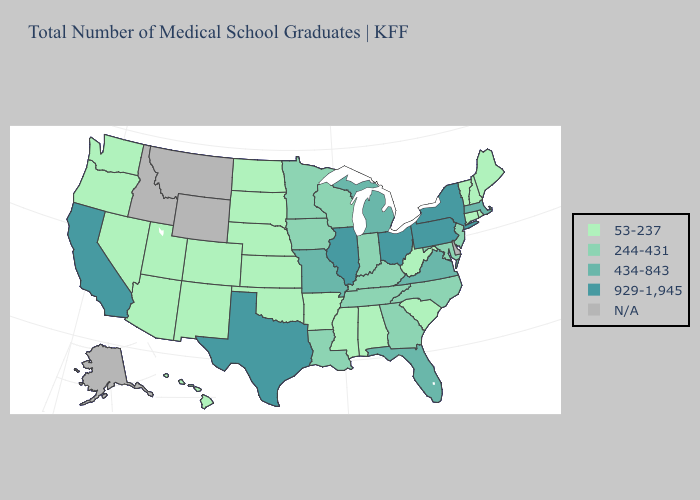Is the legend a continuous bar?
Concise answer only. No. Name the states that have a value in the range 929-1,945?
Concise answer only. California, Illinois, New York, Ohio, Pennsylvania, Texas. Does the first symbol in the legend represent the smallest category?
Give a very brief answer. Yes. Does Mississippi have the highest value in the South?
Concise answer only. No. What is the value of Montana?
Write a very short answer. N/A. Name the states that have a value in the range 53-237?
Keep it brief. Alabama, Arizona, Arkansas, Colorado, Connecticut, Hawaii, Kansas, Maine, Mississippi, Nebraska, Nevada, New Hampshire, New Mexico, North Dakota, Oklahoma, Oregon, Rhode Island, South Carolina, South Dakota, Utah, Vermont, Washington, West Virginia. How many symbols are there in the legend?
Keep it brief. 5. What is the value of Alaska?
Give a very brief answer. N/A. Does the map have missing data?
Concise answer only. Yes. What is the value of Virginia?
Quick response, please. 434-843. What is the value of Mississippi?
Keep it brief. 53-237. How many symbols are there in the legend?
Answer briefly. 5. Does New Hampshire have the highest value in the USA?
Answer briefly. No. Name the states that have a value in the range 53-237?
Answer briefly. Alabama, Arizona, Arkansas, Colorado, Connecticut, Hawaii, Kansas, Maine, Mississippi, Nebraska, Nevada, New Hampshire, New Mexico, North Dakota, Oklahoma, Oregon, Rhode Island, South Carolina, South Dakota, Utah, Vermont, Washington, West Virginia. Among the states that border Delaware , which have the highest value?
Answer briefly. Pennsylvania. 